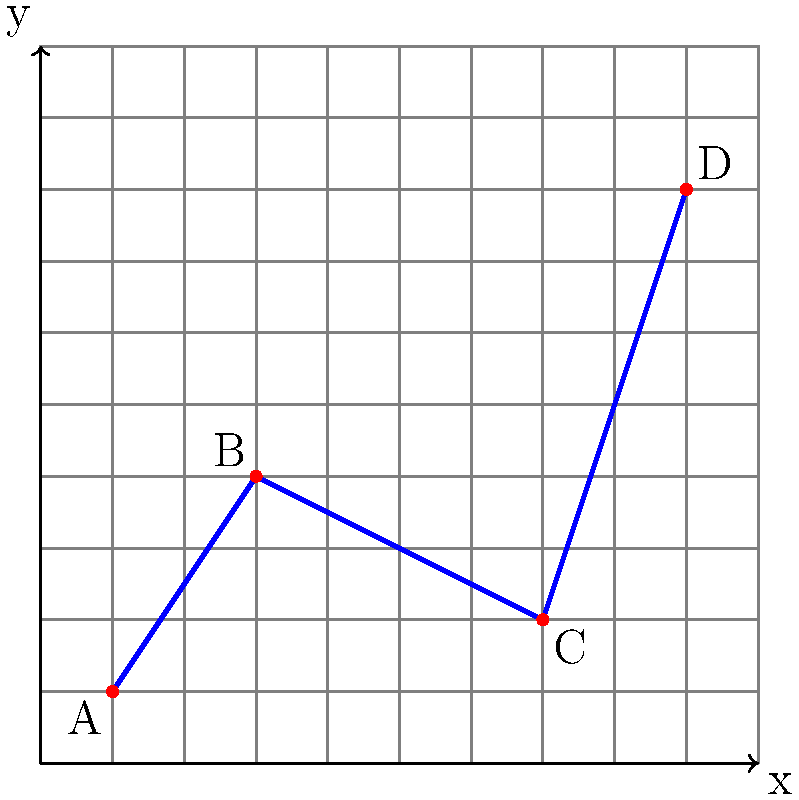As a diplomatic envoy, you're tasked with analyzing the movement path of a character in a 2D game to foster understanding between different gaming communities. The character moves from point A to point D, passing through points B and C. Given the coordinates A(1,1), B(3,4), C(7,2), and D(9,8), calculate the total Manhattan distance traveled by the character along this path. To solve this problem, we need to follow these steps:

1. Understand Manhattan distance:
   Manhattan distance is the sum of the absolute differences of the coordinates. For two points $(x_1, y_1)$ and $(x_2, y_2)$, the Manhattan distance is $|x_2 - x_1| + |y_2 - y_1|$.

2. Calculate the Manhattan distance for each segment of the path:

   a) From A(1,1) to B(3,4):
      $|3 - 1| + |4 - 1| = 2 + 3 = 5$

   b) From B(3,4) to C(7,2):
      $|7 - 3| + |2 - 4| = 4 + 2 = 6$

   c) From C(7,2) to D(9,8):
      $|9 - 7| + |8 - 2| = 2 + 6 = 8$

3. Sum up all the distances:
   Total Manhattan distance = 5 + 6 + 8 = 19

Therefore, the total Manhattan distance traveled by the character is 19 units.
Answer: 19 units 